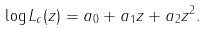<formula> <loc_0><loc_0><loc_500><loc_500>\log L _ { c } ( z ) = a _ { 0 } + a _ { 1 } z + a _ { 2 } z ^ { 2 } .</formula> 